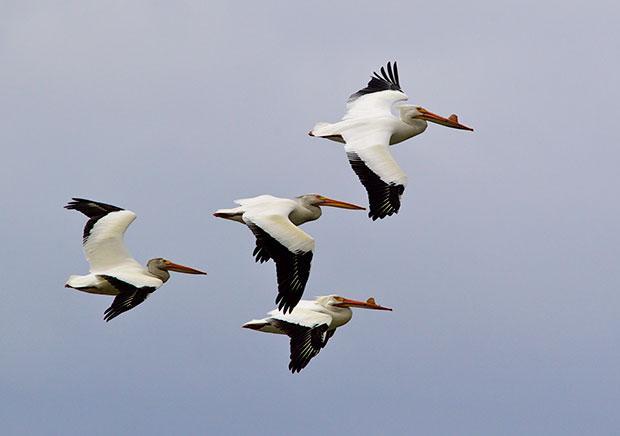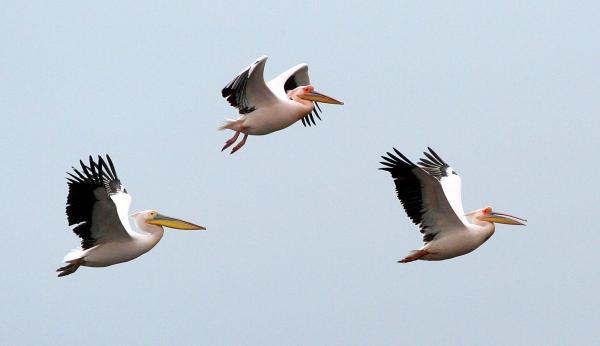The first image is the image on the left, the second image is the image on the right. Examine the images to the left and right. Is the description "There are no more than 4 pelicans." accurate? Answer yes or no. No. The first image is the image on the left, the second image is the image on the right. Considering the images on both sides, is "AT least 2 black and white pelicans are flying to the right." valid? Answer yes or no. Yes. 